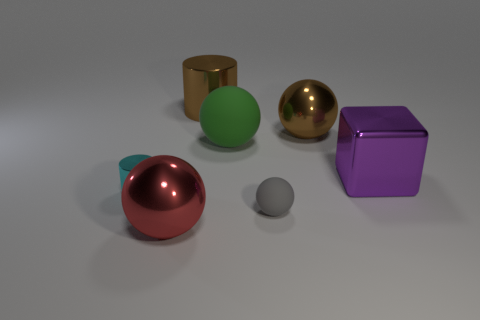Add 1 green matte things. How many objects exist? 8 Subtract all blocks. How many objects are left? 6 Subtract all big balls. Subtract all red balls. How many objects are left? 3 Add 3 big metal blocks. How many big metal blocks are left? 4 Add 5 small gray spheres. How many small gray spheres exist? 6 Subtract 0 purple spheres. How many objects are left? 7 